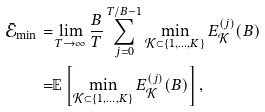<formula> <loc_0><loc_0><loc_500><loc_500>\bar { \mathcal { E } } _ { \min } = & \lim _ { T \rightarrow \infty } \frac { B } { T } \sum _ { j = 0 } ^ { T / B - 1 } \min _ { \mathcal { K } \subset \{ 1 , \dots , K \} } E _ { \mathcal { K } } ^ { ( j ) } ( B ) \\ = & \mathbb { E } \left [ \min _ { \mathcal { K } \subset \{ 1 , \dots , K \} } E _ { \mathcal { K } } ^ { ( j ) } ( B ) \right ] ,</formula> 